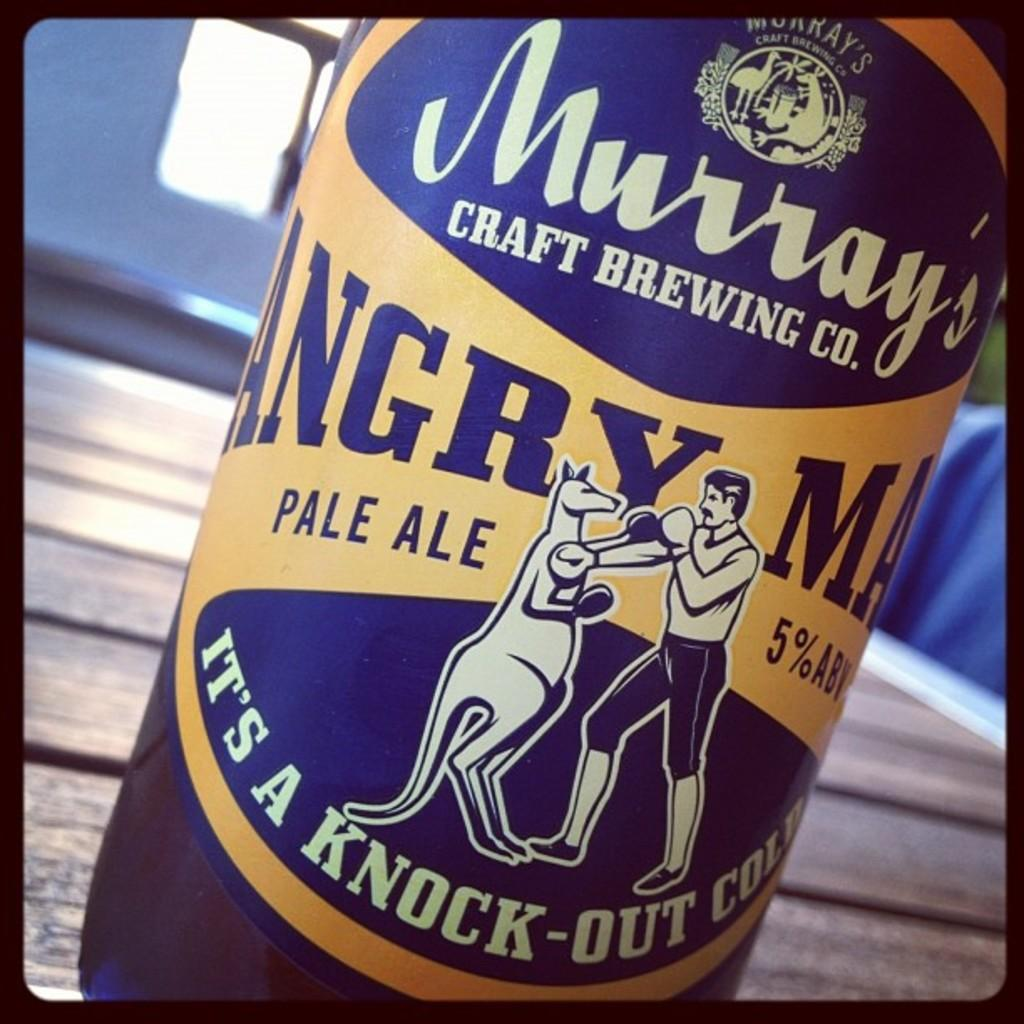<image>
Write a terse but informative summary of the picture. The blue yellow pale ale from Murray's Brewing Company label 